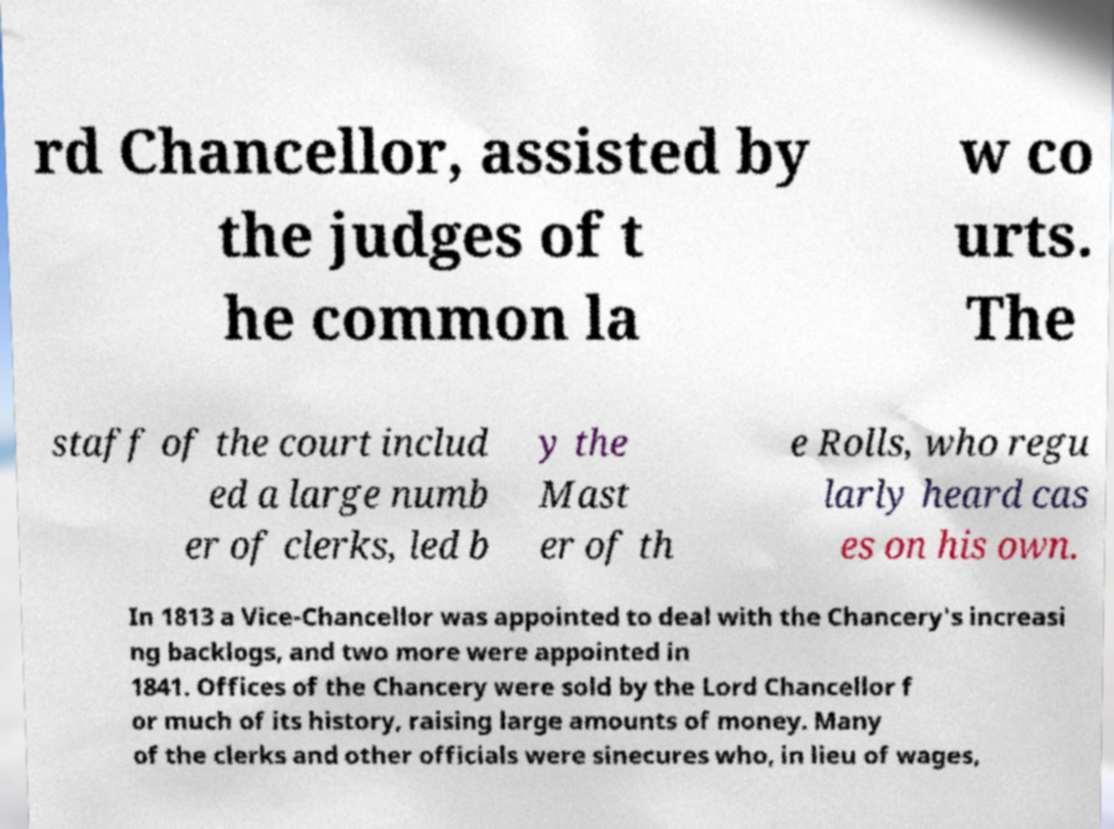There's text embedded in this image that I need extracted. Can you transcribe it verbatim? rd Chancellor, assisted by the judges of t he common la w co urts. The staff of the court includ ed a large numb er of clerks, led b y the Mast er of th e Rolls, who regu larly heard cas es on his own. In 1813 a Vice-Chancellor was appointed to deal with the Chancery's increasi ng backlogs, and two more were appointed in 1841. Offices of the Chancery were sold by the Lord Chancellor f or much of its history, raising large amounts of money. Many of the clerks and other officials were sinecures who, in lieu of wages, 